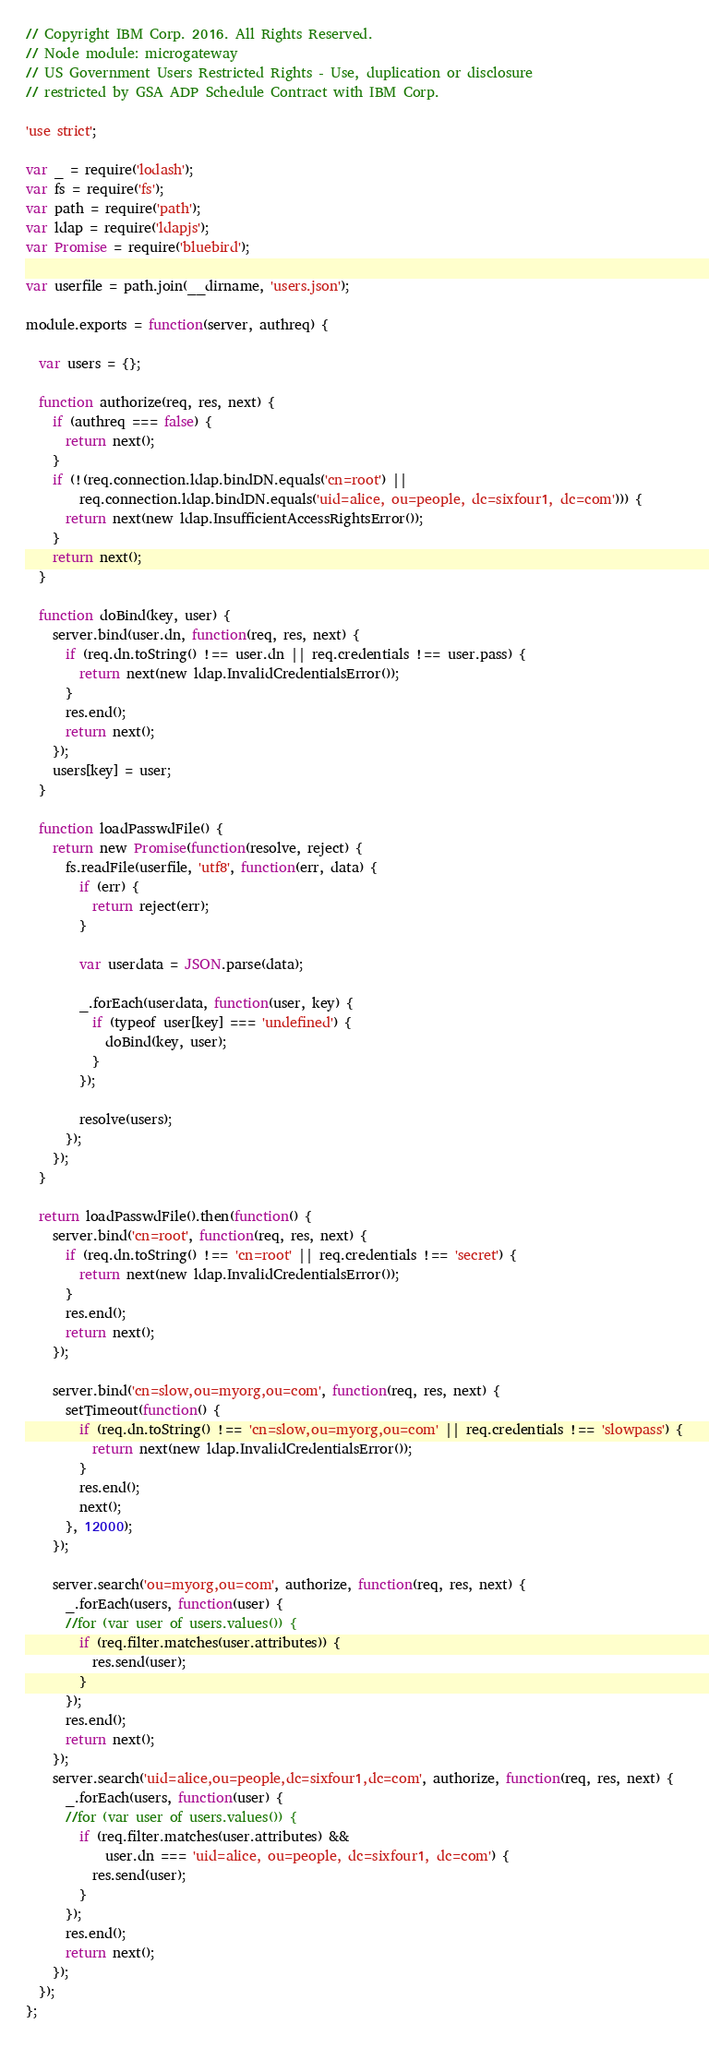Convert code to text. <code><loc_0><loc_0><loc_500><loc_500><_JavaScript_>// Copyright IBM Corp. 2016. All Rights Reserved.
// Node module: microgateway
// US Government Users Restricted Rights - Use, duplication or disclosure
// restricted by GSA ADP Schedule Contract with IBM Corp.

'use strict';

var _ = require('lodash');
var fs = require('fs');
var path = require('path');
var ldap = require('ldapjs');
var Promise = require('bluebird');

var userfile = path.join(__dirname, 'users.json');

module.exports = function(server, authreq) {

  var users = {};

  function authorize(req, res, next) {
    if (authreq === false) {
      return next();
    }
    if (!(req.connection.ldap.bindDN.equals('cn=root') ||
        req.connection.ldap.bindDN.equals('uid=alice, ou=people, dc=sixfour1, dc=com'))) {
      return next(new ldap.InsufficientAccessRightsError());
    }
    return next();
  }

  function doBind(key, user) {
    server.bind(user.dn, function(req, res, next) {
      if (req.dn.toString() !== user.dn || req.credentials !== user.pass) {
        return next(new ldap.InvalidCredentialsError());
      }
      res.end();
      return next();
    });
    users[key] = user;
  }

  function loadPasswdFile() {
    return new Promise(function(resolve, reject) {
      fs.readFile(userfile, 'utf8', function(err, data) {
        if (err) {
          return reject(err);
        }

        var userdata = JSON.parse(data);

        _.forEach(userdata, function(user, key) {
          if (typeof user[key] === 'undefined') {
            doBind(key, user);
          }
        });

        resolve(users);
      });
    });
  }

  return loadPasswdFile().then(function() {
    server.bind('cn=root', function(req, res, next) {
      if (req.dn.toString() !== 'cn=root' || req.credentials !== 'secret') {
        return next(new ldap.InvalidCredentialsError());
      }
      res.end();
      return next();
    });

    server.bind('cn=slow,ou=myorg,ou=com', function(req, res, next) {
      setTimeout(function() {
        if (req.dn.toString() !== 'cn=slow,ou=myorg,ou=com' || req.credentials !== 'slowpass') {
          return next(new ldap.InvalidCredentialsError());
        }
        res.end();
        next();
      }, 12000);
    });

    server.search('ou=myorg,ou=com', authorize, function(req, res, next) {
      _.forEach(users, function(user) {
      //for (var user of users.values()) {
        if (req.filter.matches(user.attributes)) {
          res.send(user);
        }
      });
      res.end();
      return next();
    });
    server.search('uid=alice,ou=people,dc=sixfour1,dc=com', authorize, function(req, res, next) {
      _.forEach(users, function(user) {
      //for (var user of users.values()) {
        if (req.filter.matches(user.attributes) &&
            user.dn === 'uid=alice, ou=people, dc=sixfour1, dc=com') {
          res.send(user);
        }
      });
      res.end();
      return next();
    });
  });
};
</code> 